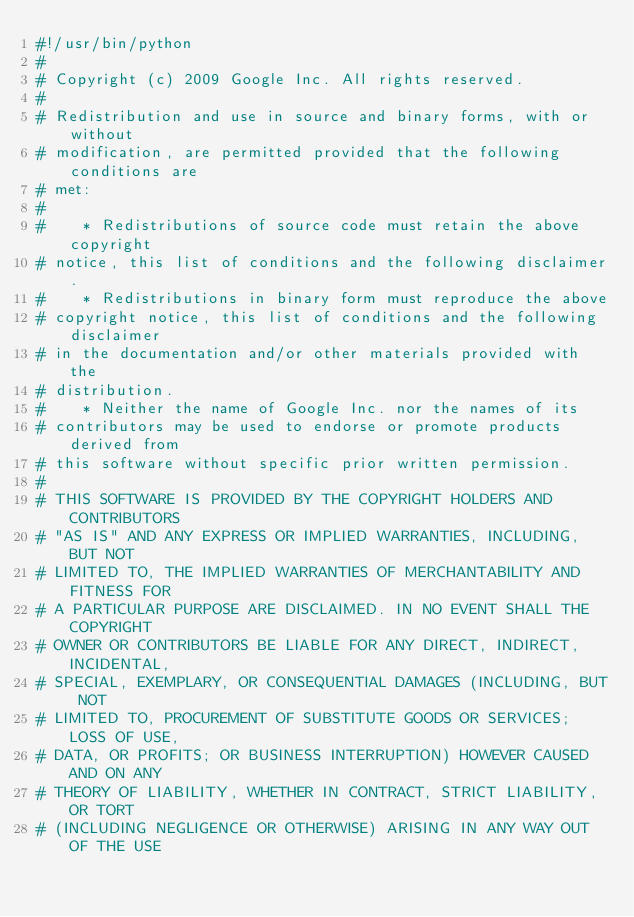<code> <loc_0><loc_0><loc_500><loc_500><_Python_>#!/usr/bin/python
#
# Copyright (c) 2009 Google Inc. All rights reserved.
#
# Redistribution and use in source and binary forms, with or without
# modification, are permitted provided that the following conditions are
# met:
#
#    * Redistributions of source code must retain the above copyright
# notice, this list of conditions and the following disclaimer.
#    * Redistributions in binary form must reproduce the above
# copyright notice, this list of conditions and the following disclaimer
# in the documentation and/or other materials provided with the
# distribution.
#    * Neither the name of Google Inc. nor the names of its
# contributors may be used to endorse or promote products derived from
# this software without specific prior written permission.
#
# THIS SOFTWARE IS PROVIDED BY THE COPYRIGHT HOLDERS AND CONTRIBUTORS
# "AS IS" AND ANY EXPRESS OR IMPLIED WARRANTIES, INCLUDING, BUT NOT
# LIMITED TO, THE IMPLIED WARRANTIES OF MERCHANTABILITY AND FITNESS FOR
# A PARTICULAR PURPOSE ARE DISCLAIMED. IN NO EVENT SHALL THE COPYRIGHT
# OWNER OR CONTRIBUTORS BE LIABLE FOR ANY DIRECT, INDIRECT, INCIDENTAL,
# SPECIAL, EXEMPLARY, OR CONSEQUENTIAL DAMAGES (INCLUDING, BUT NOT
# LIMITED TO, PROCUREMENT OF SUBSTITUTE GOODS OR SERVICES; LOSS OF USE,
# DATA, OR PROFITS; OR BUSINESS INTERRUPTION) HOWEVER CAUSED AND ON ANY
# THEORY OF LIABILITY, WHETHER IN CONTRACT, STRICT LIABILITY, OR TORT
# (INCLUDING NEGLIGENCE OR OTHERWISE) ARISING IN ANY WAY OUT OF THE USE</code> 